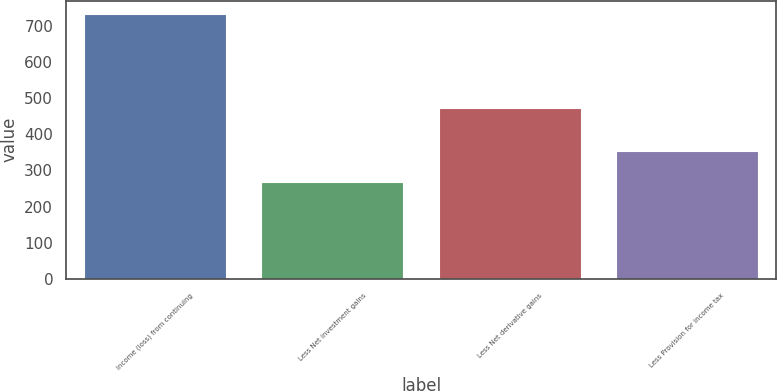<chart> <loc_0><loc_0><loc_500><loc_500><bar_chart><fcel>Income (loss) from continuing<fcel>Less Net investment gains<fcel>Less Net derivative gains<fcel>Less Provision for income tax<nl><fcel>733<fcel>269<fcel>474<fcel>354<nl></chart> 